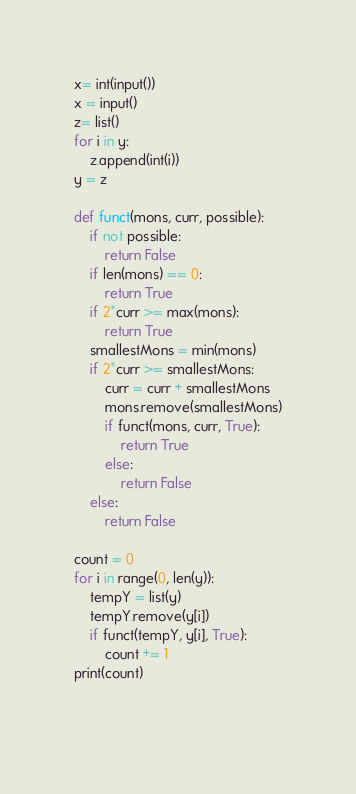<code> <loc_0><loc_0><loc_500><loc_500><_Python_>
x= int(input())
x = input()
z= list()
for i in y:
    z.append(int(i))
y = z

def funct(mons, curr, possible):
    if not possible:
        return False
    if len(mons) == 0:
        return True
    if 2*curr >= max(mons):
        return True
    smallestMons = min(mons)
    if 2*curr >= smallestMons:
        curr = curr + smallestMons
        mons.remove(smallestMons)
        if funct(mons, curr, True):
            return True
        else:
            return False
    else:
        return False

count = 0
for i in range(0, len(y)):
    tempY = list(y)
    tempY.remove(y[i])
    if funct(tempY, y[i], True):
        count += 1
print(count)
        
  

</code> 